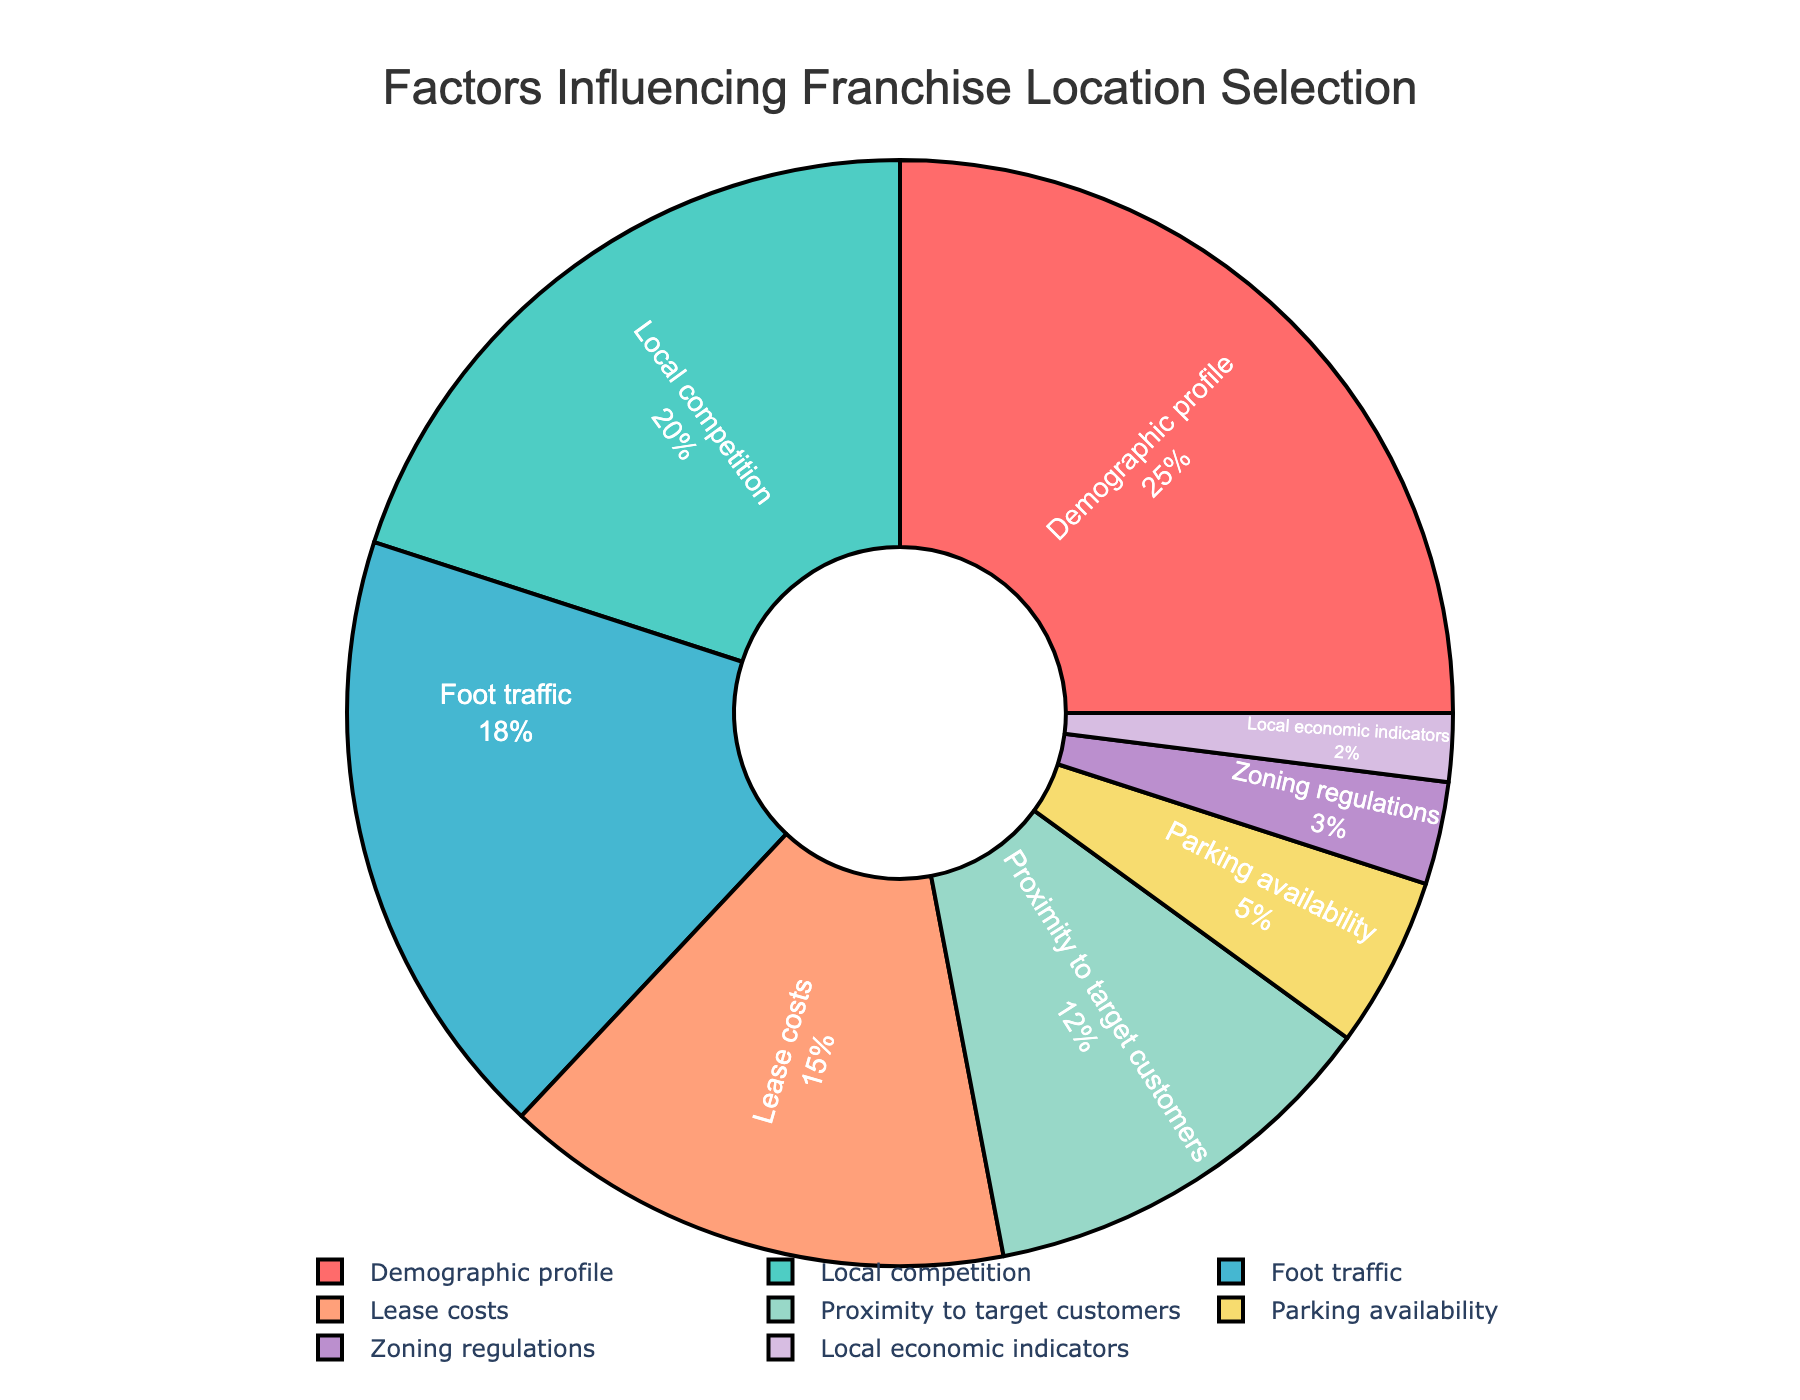What is the most influential factor in franchise location selection? By looking at the pie chart, we can see that the largest segment is labeled "Demographic profile," which occupies 25% of the total. Thus, it is the most influential factor.
Answer: Demographic profile Which factor has the least influence on franchise location selection? The smallest segment in the pie chart corresponds to "Local economic indicators," which holds only 2% of the total. Thus, it is the least influential factor.
Answer: Local economic indicators How much more significant is the demographic profile compared to parking availability? The demographic profile accounts for 25%, whereas parking availability accounts for 5%. To find how much more significant the demographic profile is, subtract 5% from 25%.
Answer: 20% Combine the percentages of local competition, foot traffic, and lease costs. What is the total? Local competition is 20%, foot traffic is 18%, and lease costs are 15%. Adding these together gives 20% + 18% + 15% = 53%.
Answer: 53% Are foot traffic and lease costs together more significant than the demographic profile? Foot traffic is 18% and lease costs are 15%, adding these together gives 18% + 15% = 33%. Since the demographic profile is 25%, 33% is greater than 25%.
Answer: Yes Which factors have a combined influence of less than 10%? Parking availability is 5%, zoning regulations are 3%, and local economic indicators are 2%. Summing these gives 5% + 3% + 2% = 10%. None exceed the combined threshold individually. However, considering their combined influence is exactly 10%, none are below 10%.
Answer: None What percentage difference exists between proximity to target customers and local competition? Proximity to target customers is 12% and local competition is 20%. Subtracting proximity's influence from local competition's gives 20% - 12% = 8%.
Answer: 8% What two factors, when combined, approximately equal foot traffic's influence? Parking availability is 5% and adding zoning regulations which are 3% gives 5% + 3% = 8%. Another try: combining proximity to target customers (12%) and local economic indicators (2%) gives 12% + 2% = 14%. However, a closer match to 18% is lease costs (15%) and local economic indicators (2%) for 15% + 2% = 17%.
Answer: Proximity to target customers and local economic indicators Which has a larger influence: zoning regulations or lease costs? The pie chart indicates that zoning regulations hold 3% and lease costs hold 15%. Clearly, lease costs have a larger influence.
Answer: Lease costs What is the visual color of the factor with the fourth highest percentage? Lease costs hold the fourth highest percentage at 15%. Referring to the pie chart, lease costs are represented by the orange segment.
Answer: Orange 